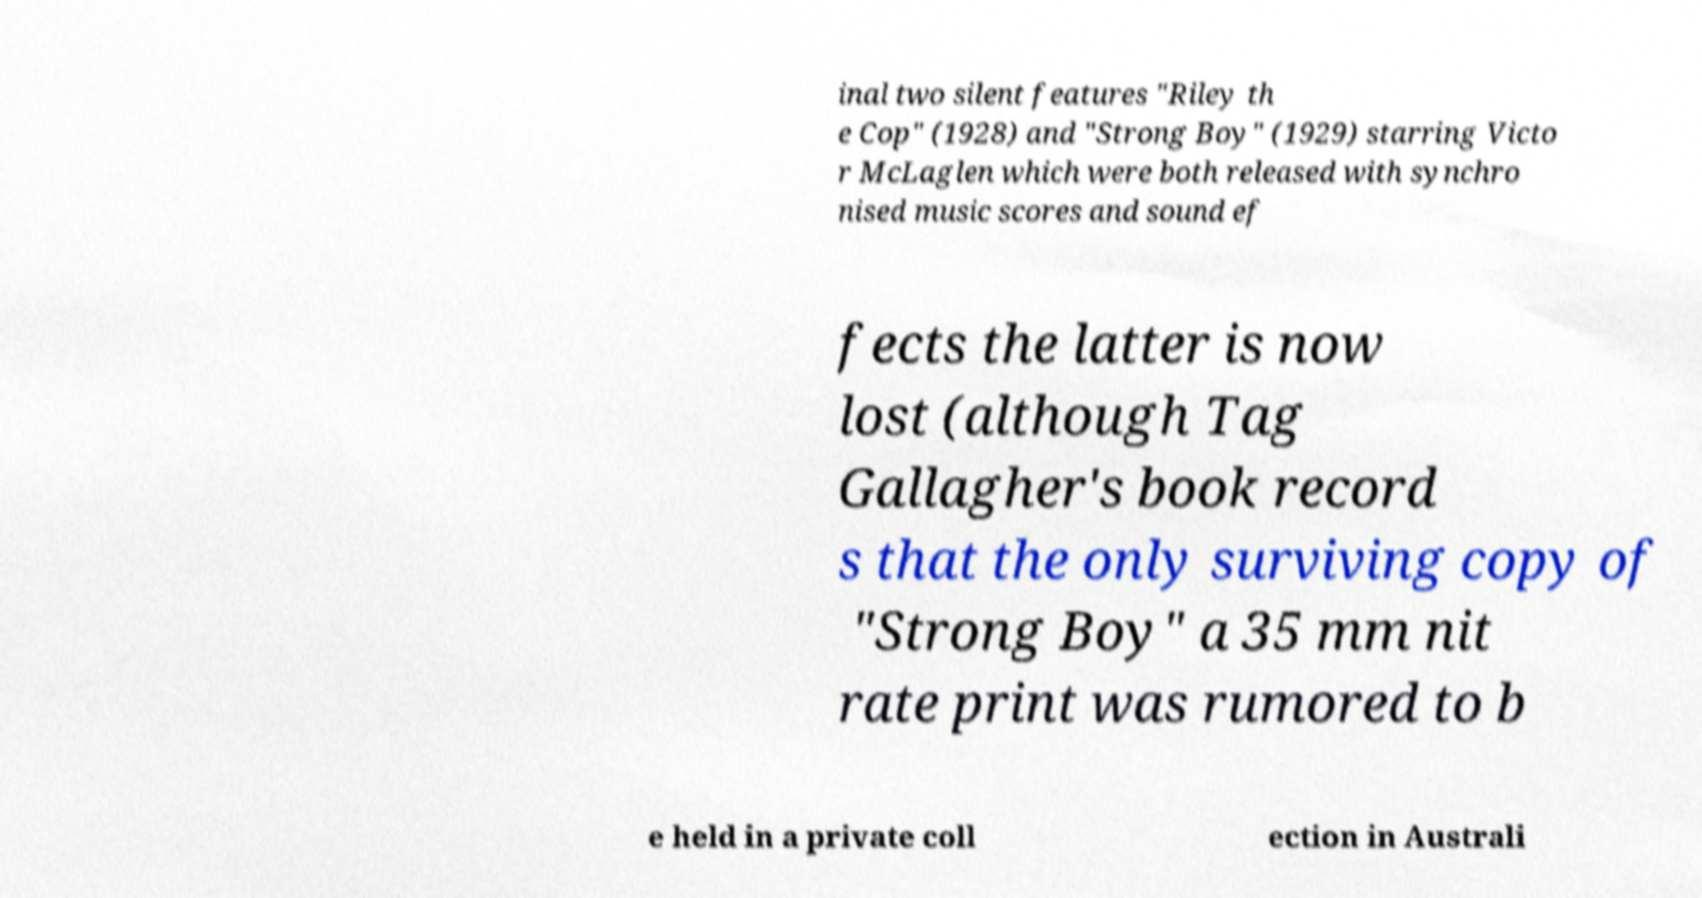I need the written content from this picture converted into text. Can you do that? inal two silent features "Riley th e Cop" (1928) and "Strong Boy" (1929) starring Victo r McLaglen which were both released with synchro nised music scores and sound ef fects the latter is now lost (although Tag Gallagher's book record s that the only surviving copy of "Strong Boy" a 35 mm nit rate print was rumored to b e held in a private coll ection in Australi 